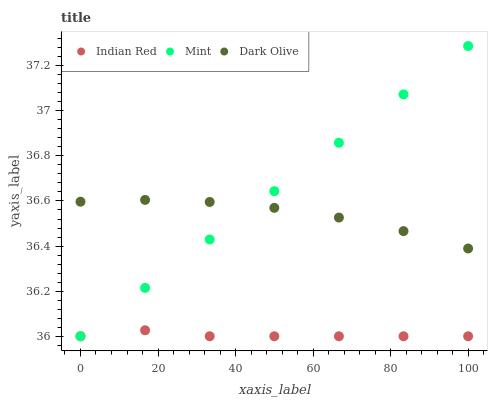Does Indian Red have the minimum area under the curve?
Answer yes or no. Yes. Does Mint have the maximum area under the curve?
Answer yes or no. Yes. Does Mint have the minimum area under the curve?
Answer yes or no. No. Does Indian Red have the maximum area under the curve?
Answer yes or no. No. Is Mint the smoothest?
Answer yes or no. Yes. Is Dark Olive the roughest?
Answer yes or no. Yes. Is Indian Red the smoothest?
Answer yes or no. No. Is Indian Red the roughest?
Answer yes or no. No. Does Mint have the lowest value?
Answer yes or no. Yes. Does Mint have the highest value?
Answer yes or no. Yes. Does Indian Red have the highest value?
Answer yes or no. No. Is Indian Red less than Dark Olive?
Answer yes or no. Yes. Is Dark Olive greater than Indian Red?
Answer yes or no. Yes. Does Dark Olive intersect Mint?
Answer yes or no. Yes. Is Dark Olive less than Mint?
Answer yes or no. No. Is Dark Olive greater than Mint?
Answer yes or no. No. Does Indian Red intersect Dark Olive?
Answer yes or no. No. 